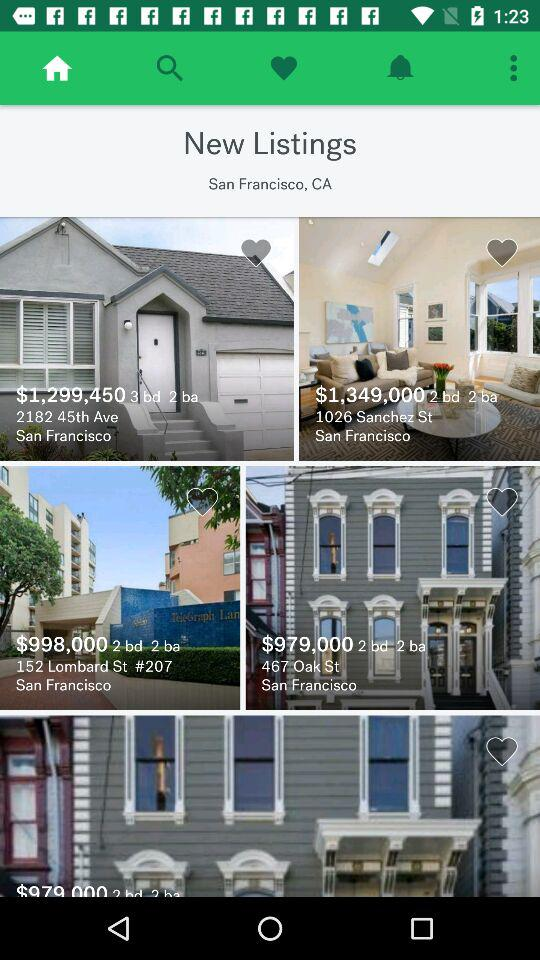What is the number of beds and baths in the house located at 2182, 45th Ave? The number of beds is 3 and baths is 2. 